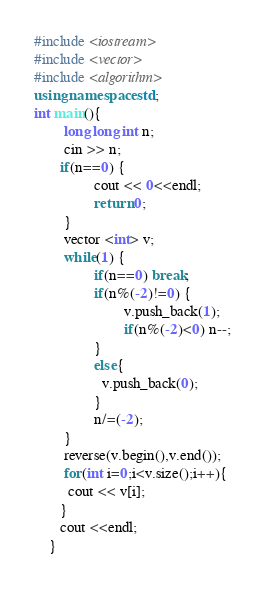Convert code to text. <code><loc_0><loc_0><loc_500><loc_500><_C++_>#include <iostream>
#include <vector>
#include <algorithm>
using namespace std;
int main(){
        long long int n;
        cin >> n;
       if(n==0) {
                cout << 0<<endl;
                return 0;
        }
        vector <int> v;
        while(1) {
                if(n==0) break;
                if(n%(-2)!=0) {
                        v.push_back(1);
                        if(n%(-2)<0) n--;
                }
                else{
                  v.push_back(0);
                }
                n/=(-2);
        }
        reverse(v.begin(),v.end());
        for(int i=0;i<v.size();i++){
         cout << v[i];
       }
       cout <<endl;
    }
</code> 